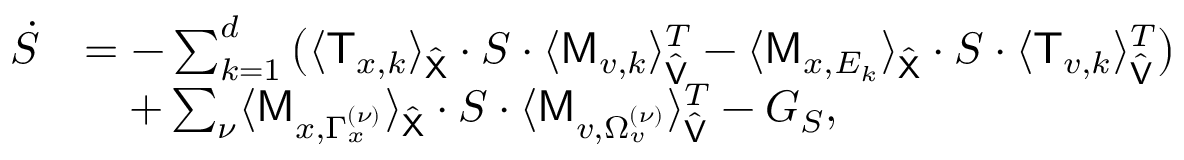Convert formula to latex. <formula><loc_0><loc_0><loc_500><loc_500>\begin{array} { r l } { \dot { S } } & { = - \sum _ { k = 1 } ^ { d } \left ( \langle \mathsf T _ { x , k } \rangle _ { \hat { \mathsf X } } \cdot S \cdot \langle \mathsf M _ { v , k } \rangle _ { \hat { \mathsf V } } ^ { T } - \langle \mathsf M _ { x , E _ { k } } \rangle _ { \hat { \mathsf X } } \cdot S \cdot \langle \mathsf T _ { v , k } \rangle _ { \hat { \mathsf V } } ^ { T } \right ) } \\ & { \quad + \sum _ { \nu } \langle \mathsf M _ { x , \Gamma _ { x } ^ { ( \nu ) } } \rangle _ { \hat { \mathsf X } } \cdot S \cdot \langle \mathsf M _ { v , \Omega _ { v } ^ { ( \nu ) } } \rangle _ { \hat { \mathsf V } } ^ { T } - G _ { S } , } \end{array}</formula> 